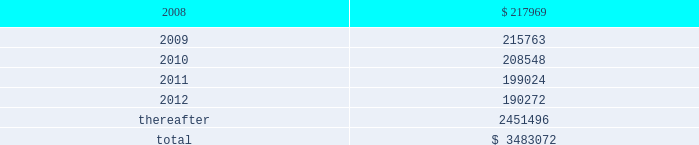American tower corporation and subsidiaries notes to consolidated financial statements 2014 ( continued ) as of december 31 , 2006 , the company held a total of ten interest rate swap agreements to manage exposure to variable rate interest obligations under its amt opco and spectrasite credit facilities and four forward starting interest rate swap agreements to manage exposure to variability in cash flows relating to forecasted interest payments in connection with the securitization which the company designated as cash flow hedges .
The eight american tower swaps had an aggregate notional amount of $ 450.0 million and fixed rates ranging between 4.63% ( 4.63 % ) and 4.88% ( 4.88 % ) and the two spectrasite swaps have an aggregate notional amount of $ 100.0 million and a fixed rate of 4.95% ( 4.95 % ) .
The four forward starting interest rate swap agreements had an aggregate notional amount of $ 900.0 million , fixed rates ranging between 4.73% ( 4.73 % ) and 5.10% ( 5.10 % ) .
As of december 31 , 2006 , the company also held three interest rate swap instruments and one interest rate cap instrument that were acquired in the spectrasite , inc .
Merger in august 2005 and were not designated as cash flow hedges .
The three interest rate swaps , which had a fair value of $ 6.7 million at the date of acquisition , have an aggregate notional amount of $ 300.0 million , a fixed rate of 3.88% ( 3.88 % ) .
The interest rate cap had a notional amount of $ 175.0 million , a fixed rate of 7.0% ( 7.0 % ) , and expired in february 2006 .
As of december 31 , 2006 , other comprehensive income includes unrealized gains on short term available-for-sale securities of $ 10.4 million and unrealized gains related to the interest rate swap agreements in the table above of $ 5.7 million , net of tax .
During the year ended december 31 , 2006 , the company recorded a net unrealized gain of approximately $ 6.5 million ( net of a tax provision of approximately $ 3.5 million ) in other comprehensive loss for the change in fair value of interest rate swaps designated as cash flow hedges and reclassified $ 0.7 million ( net of an income tax benefit of $ 0.2 million ) into results of operations during the year ended december 31 , 2006 .
Commitments and contingencies lease obligations 2014the company leases certain land , office and tower space under operating leases that expire over various terms .
Many of the leases contain renewal options with specified increases in lease payments upon exercise of the renewal option .
Escalation clauses present in operating leases , excluding those tied to cpi or other inflation-based indices , are recognized on a straight-line basis over the non-cancelable term of the lease .
( see note 1. ) future minimum rental payments under non-cancelable operating leases include payments for certain renewal periods at the company 2019s option because failure to renew could result in a loss of the applicable tower site and related revenues from tenant leases , thereby making it reasonably assured that the company will renew the lease .
Such payments in effect at december 31 , 2007 are as follows ( in thousands ) : year ending december 31 .
Aggregate rent expense ( including the effect of straight-line rent expense ) under operating leases for the years ended december 31 , 2007 , 2006 and 2005 approximated $ 246.4 million , $ 237.0 million and $ 168.7 million , respectively. .
What is the percentage change in aggregate rent expense from 2005 to 2006? 
Computations: ((237.0 - 168.7) / 168.7)
Answer: 0.40486. 